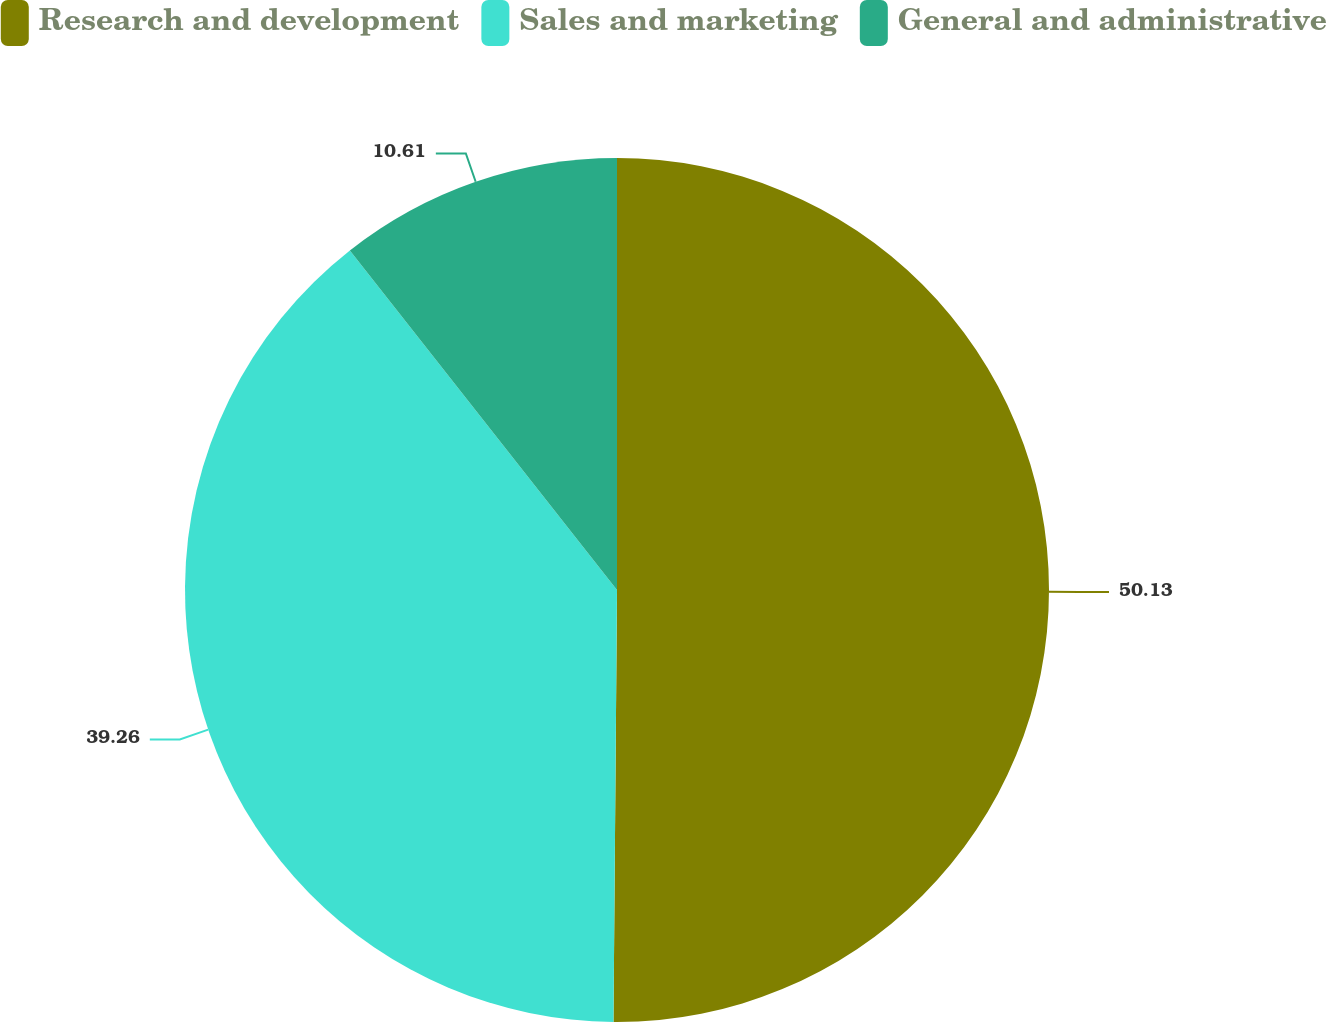Convert chart to OTSL. <chart><loc_0><loc_0><loc_500><loc_500><pie_chart><fcel>Research and development<fcel>Sales and marketing<fcel>General and administrative<nl><fcel>50.13%<fcel>39.26%<fcel>10.61%<nl></chart> 